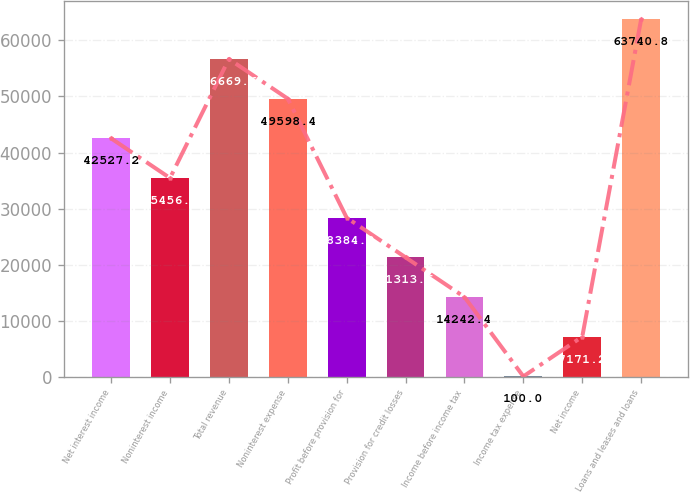Convert chart. <chart><loc_0><loc_0><loc_500><loc_500><bar_chart><fcel>Net interest income<fcel>Noninterest income<fcel>Total revenue<fcel>Noninterest expense<fcel>Profit before provision for<fcel>Provision for credit losses<fcel>Income before income tax<fcel>Income tax expense<fcel>Net income<fcel>Loans and leases and loans<nl><fcel>42527.2<fcel>35456<fcel>56669.6<fcel>49598.4<fcel>28384.8<fcel>21313.6<fcel>14242.4<fcel>100<fcel>7171.2<fcel>63740.8<nl></chart> 